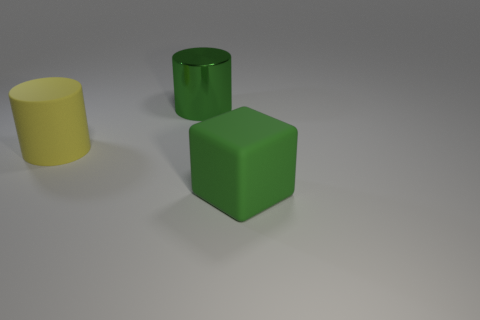There is a yellow thing that is the same size as the green cylinder; what is its shape?
Provide a succinct answer. Cylinder. Does the block have the same material as the big green cylinder?
Your answer should be very brief. No. What number of rubber objects are either big objects or big cylinders?
Your response must be concise. 2. There is another big thing that is the same color as the big shiny object; what shape is it?
Your answer should be compact. Cube. There is a object to the right of the green cylinder; is it the same color as the metal cylinder?
Make the answer very short. Yes. What shape is the large green thing that is right of the green thing behind the green matte thing?
Ensure brevity in your answer.  Cube. What number of objects are cylinders to the left of the metallic object or objects to the right of the large yellow thing?
Offer a terse response. 3. There is a big thing that is made of the same material as the yellow cylinder; what shape is it?
Ensure brevity in your answer.  Cube. Are there any other things that have the same color as the block?
Ensure brevity in your answer.  Yes. What material is the other big yellow thing that is the same shape as the metallic thing?
Your answer should be very brief. Rubber. 